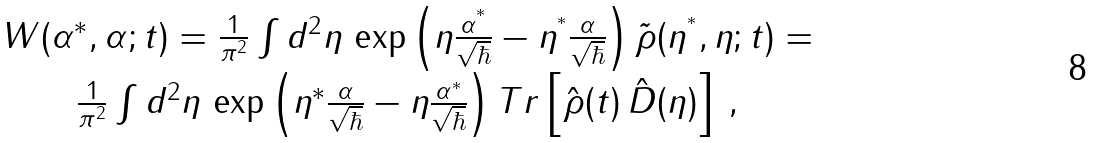<formula> <loc_0><loc_0><loc_500><loc_500>\begin{array} { c } W ( \alpha ^ { * } , \alpha ; t ) = \frac { 1 } { \pi ^ { 2 } } \int d ^ { 2 } \eta \, \exp \left ( \eta \frac { \alpha ^ { ^ { * } } } { \sqrt { \hbar } } - \eta ^ { ^ { * } } \frac { \alpha } { \sqrt { \hbar } } \right ) \tilde { \rho } ( \eta ^ { ^ { * } } , \eta ; t ) = \\ \frac { 1 } { \pi ^ { 2 } } \int d ^ { 2 } \eta \, \exp \left ( \eta ^ { * } \frac { \alpha } { \sqrt { \hbar } } - \eta \frac { \alpha ^ { * } } { \sqrt { \hbar } } \right ) T r \left [ { \hat { \rho } ( t ) } \, { \hat { D } ( \eta ) } \right ] \, , \end{array}</formula> 